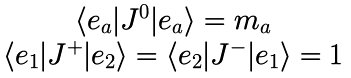<formula> <loc_0><loc_0><loc_500><loc_500>\begin{array} { c } \langle e _ { a } | J ^ { 0 } | e _ { a } \rangle = m _ { a } \\ \langle e _ { 1 } | J ^ { + } | e _ { 2 } \rangle = \langle e _ { 2 } | J ^ { - } | e _ { 1 } \rangle = 1 \end{array}</formula> 